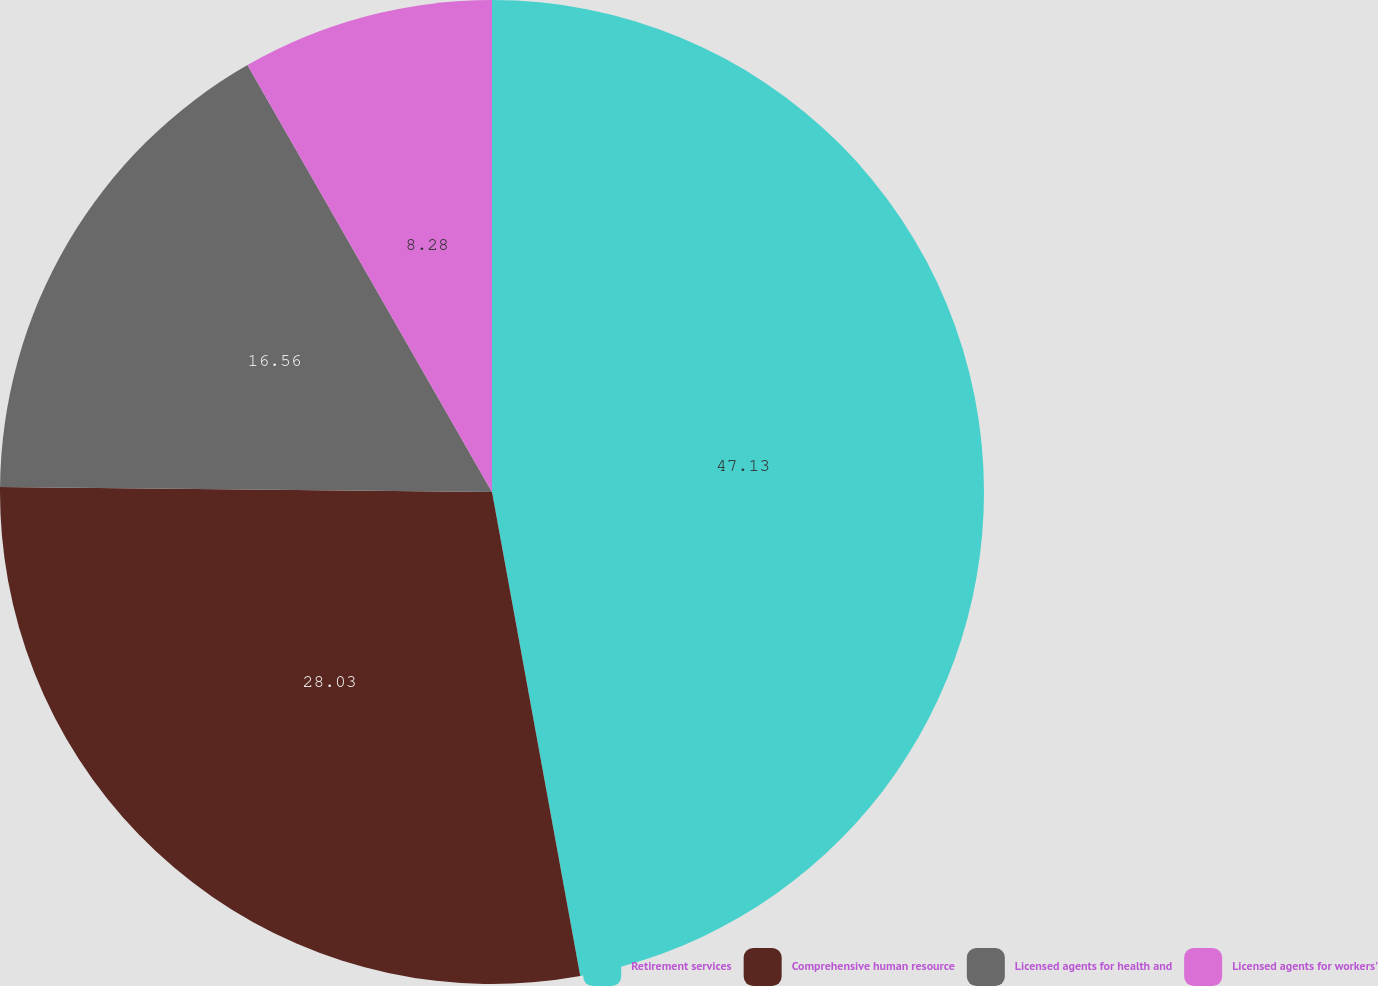Convert chart. <chart><loc_0><loc_0><loc_500><loc_500><pie_chart><fcel>Retirement services<fcel>Comprehensive human resource<fcel>Licensed agents for health and<fcel>Licensed agents for workers'<nl><fcel>47.13%<fcel>28.03%<fcel>16.56%<fcel>8.28%<nl></chart> 